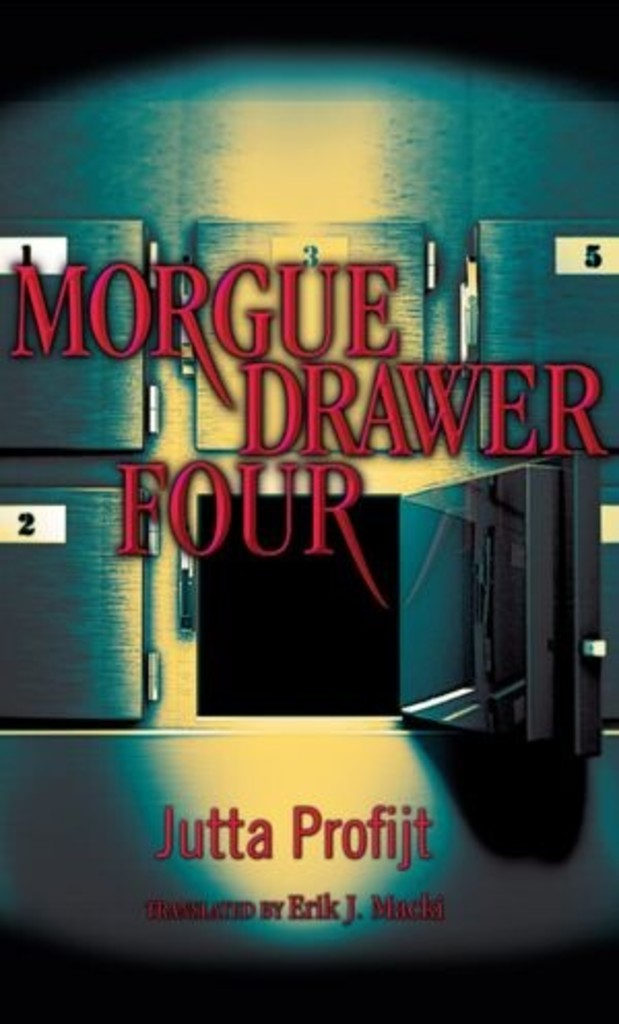What is this photo about? The image displays the intriguing book cover for 'Morgue Drawer Four' by Jutta Profijt, translated by Erik J. Macki. The cover portrays a mysterious and vaguely unsettling ambiance with its depiction of a dimly lit hallway lined with numbered doors, indicative of a morgue setting. The eerie setting hints at a thrilling narrative filled with suspense and possibly supernatural elements. Emphasized by the large, bold title at the top, the design complements the eerie and suspenseful themes likely explored in the book, making it an appealing pick for fans of crime and mystery genres. 